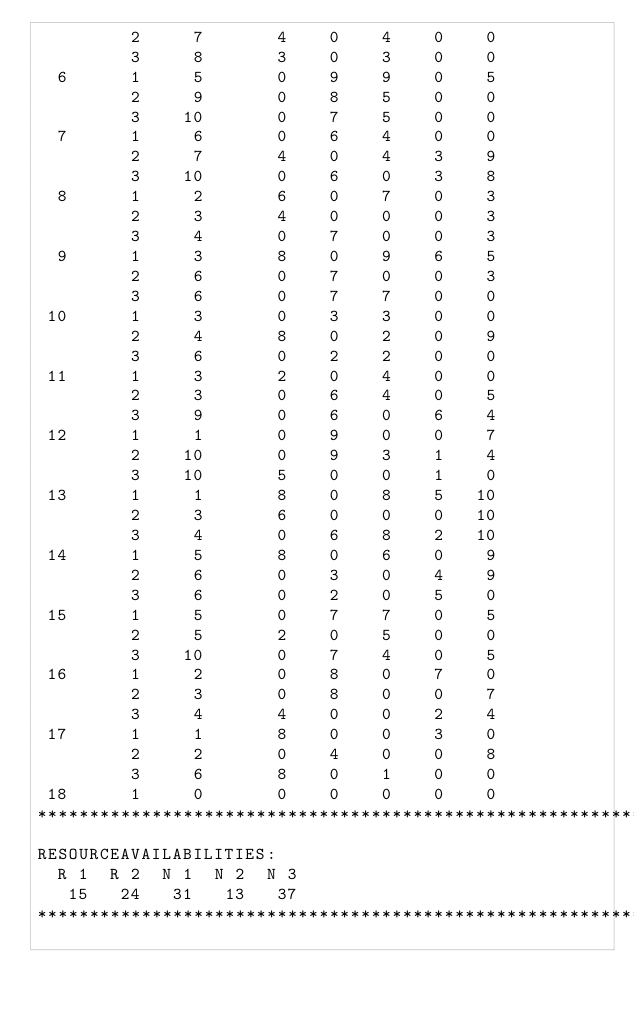<code> <loc_0><loc_0><loc_500><loc_500><_ObjectiveC_>         2     7       4    0    4    0    0
         3     8       3    0    3    0    0
  6      1     5       0    9    9    0    5
         2     9       0    8    5    0    0
         3    10       0    7    5    0    0
  7      1     6       0    6    4    0    0
         2     7       4    0    4    3    9
         3    10       0    6    0    3    8
  8      1     2       6    0    7    0    3
         2     3       4    0    0    0    3
         3     4       0    7    0    0    3
  9      1     3       8    0    9    6    5
         2     6       0    7    0    0    3
         3     6       0    7    7    0    0
 10      1     3       0    3    3    0    0
         2     4       8    0    2    0    9
         3     6       0    2    2    0    0
 11      1     3       2    0    4    0    0
         2     3       0    6    4    0    5
         3     9       0    6    0    6    4
 12      1     1       0    9    0    0    7
         2    10       0    9    3    1    4
         3    10       5    0    0    1    0
 13      1     1       8    0    8    5   10
         2     3       6    0    0    0   10
         3     4       0    6    8    2   10
 14      1     5       8    0    6    0    9
         2     6       0    3    0    4    9
         3     6       0    2    0    5    0
 15      1     5       0    7    7    0    5
         2     5       2    0    5    0    0
         3    10       0    7    4    0    5
 16      1     2       0    8    0    7    0
         2     3       0    8    0    0    7
         3     4       4    0    0    2    4
 17      1     1       8    0    0    3    0
         2     2       0    4    0    0    8
         3     6       8    0    1    0    0
 18      1     0       0    0    0    0    0
************************************************************************
RESOURCEAVAILABILITIES:
  R 1  R 2  N 1  N 2  N 3
   15   24   31   13   37
************************************************************************
</code> 